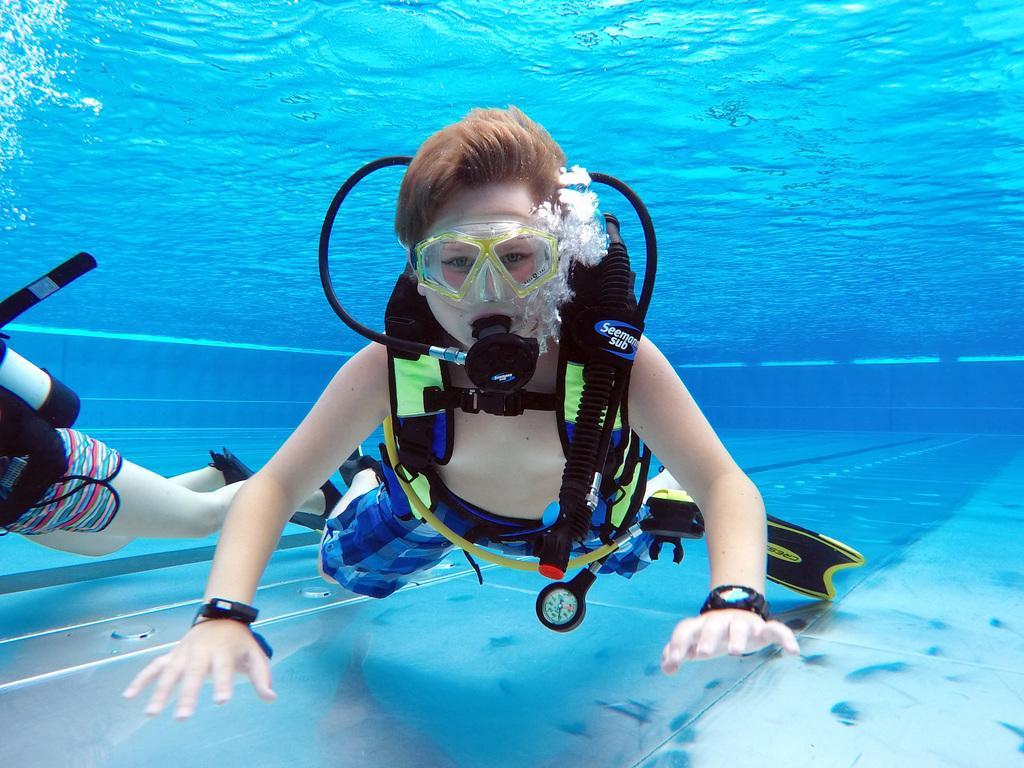How many people are in the image? There are two people in the image. What are the people wearing in the image? The people are wearing swimming costumes. Where are the people located in the image? The people are visible in the water. What type of laborer can be seen working in the image? There is no laborer present in the image; it features two people wearing swimming costumes in the water. 